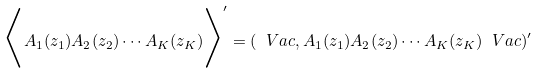<formula> <loc_0><loc_0><loc_500><loc_500>\Big < A _ { 1 } ( z _ { 1 } ) A _ { 2 } ( z _ { 2 } ) \cdots A _ { K } ( z _ { K } ) \Big > ^ { \prime } = ( \ V a c , A _ { 1 } ( z _ { 1 } ) A _ { 2 } ( z _ { 2 } ) \cdots A _ { K } ( z _ { K } ) \ V a c ) ^ { \prime }</formula> 